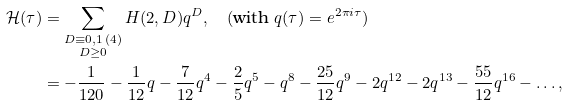Convert formula to latex. <formula><loc_0><loc_0><loc_500><loc_500>\mathcal { H } ( \tau ) & = \sum _ { \substack { D \equiv 0 , 1 \, ( 4 ) \\ D \geq 0 } } H ( 2 , D ) q ^ { D } , \quad ( \text {with $q(\tau)=e^{2\pi i\tau}$} ) \\ & = - \frac { 1 } { 1 2 0 } - \frac { 1 } { 1 2 } q - \frac { 7 } { 1 2 } q ^ { 4 } - \frac { 2 } { 5 } q ^ { 5 } - q ^ { 8 } - \frac { 2 5 } { 1 2 } q ^ { 9 } - 2 q ^ { 1 2 } - 2 q ^ { 1 3 } - \frac { 5 5 } { 1 2 } q ^ { 1 6 } - \dots ,</formula> 